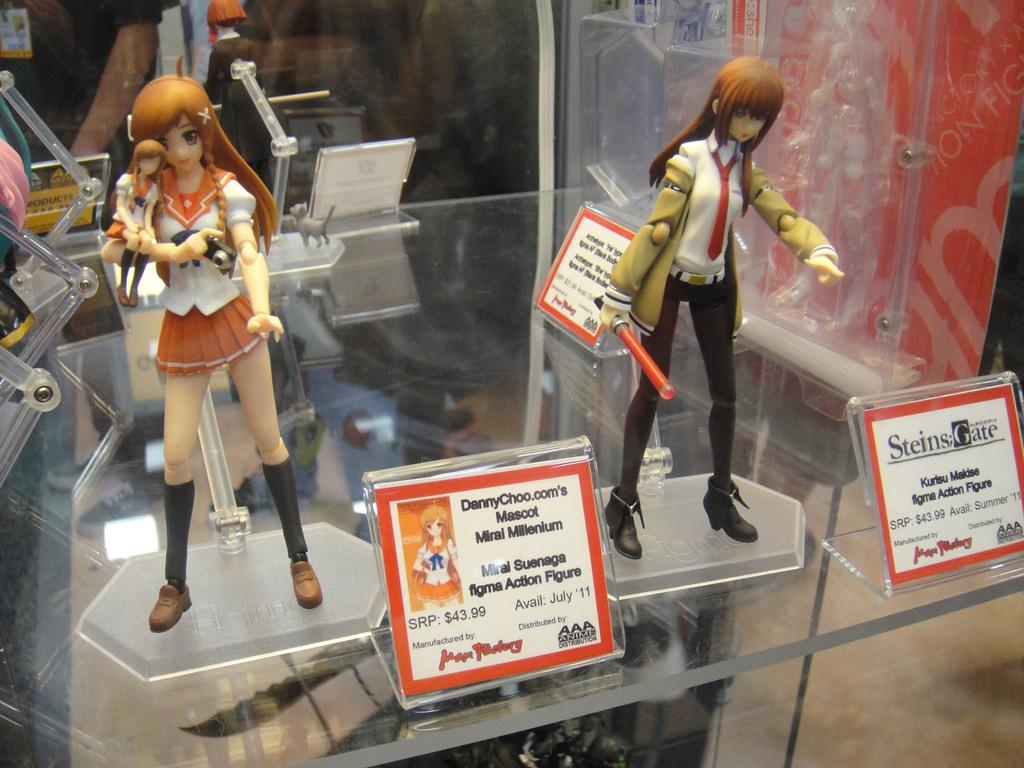What objects are on the glass table in the image? There are toys on a glass table in the image. What else can be seen in the image besides the toys? There are boards with text in the image. Can you describe the person visible in the background of the image? Unfortunately, the provided facts do not give enough information to describe the person in the background. What type of harmony is being taught in the class visible in the image? There is no class or reference to harmony in the image; it features toys on a glass table and boards with text. What type of party is being held in the image? There is no party visible in the image; it features toys on a glass table and boards with text. 